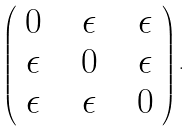<formula> <loc_0><loc_0><loc_500><loc_500>\left ( \begin{array} { c c c } 0 \ \ & \epsilon \ \ & \epsilon \\ \epsilon \ \ & 0 \ \ & \epsilon \\ \epsilon \ \ & \epsilon \ \ & 0 \end{array} \right ) .</formula> 